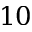Convert formula to latex. <formula><loc_0><loc_0><loc_500><loc_500>1 0</formula> 